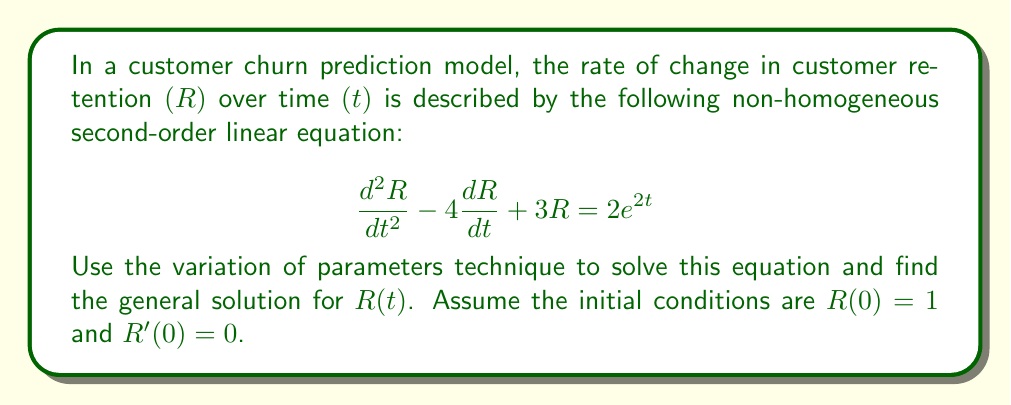Solve this math problem. To solve this non-homogeneous second-order linear equation using the variation of parameters technique, we'll follow these steps:

1) First, solve the homogeneous equation:
   $$\frac{d^2R}{dt^2} - 4\frac{dR}{dt} + 3R = 0$$
   The characteristic equation is $r^2 - 4r + 3 = 0$, which has roots $r_1 = 1$ and $r_2 = 3$.
   The general solution to the homogeneous equation is:
   $$R_h(t) = c_1e^t + c_2e^{3t}$$

2) Now, we'll use variation of parameters to find a particular solution. Let:
   $$R_p(t) = u_1(t)e^t + u_2(t)e^{3t}$$

3) We need to solve the system:
   $$\begin{align}
   u_1'e^t + u_2'e^{3t} &= 0 \\
   u_1'e^t + 3u_2'e^{3t} &= 2e^{2t}
   \end{align}$$

4) Solving this system:
   $$\begin{align}
   u_1' &= -2e^t \\
   u_2' &= e^{-t}
   \end{align}$$

5) Integrating:
   $$\begin{align}
   u_1 &= -2e^t + C_1 \\
   u_2 &= -e^{-t} + C_2
   \end{align}$$

6) The particular solution is:
   $$R_p(t) = (-2e^t + C_1)e^t + (-e^{-t} + C_2)e^{3t} = -2e^{2t} - e^{2t} + C_1e^t + C_2e^{3t}$$

7) The general solution is the sum of the homogeneous and particular solutions:
   $$R(t) = R_h(t) + R_p(t) = (c_1 + C_1)e^t + (c_2 + C_2)e^{3t} - 3e^{2t}$$

8) Simplify by combining constants:
   $$R(t) = Ae^t + Be^{3t} - 3e^{2t}$$

9) To find $A$ and $B$, use the initial conditions:
   $R(0) = 1$ gives: $A + B - 3 = 1$
   $R'(0) = 0$ gives: $A + 3B - 6 = 0$

10) Solving these equations:
    $A = 4$, $B = 0$

Therefore, the final solution is:
$$R(t) = 4e^t - 3e^{2t}$$
Answer: $$R(t) = 4e^t - 3e^{2t}$$ 